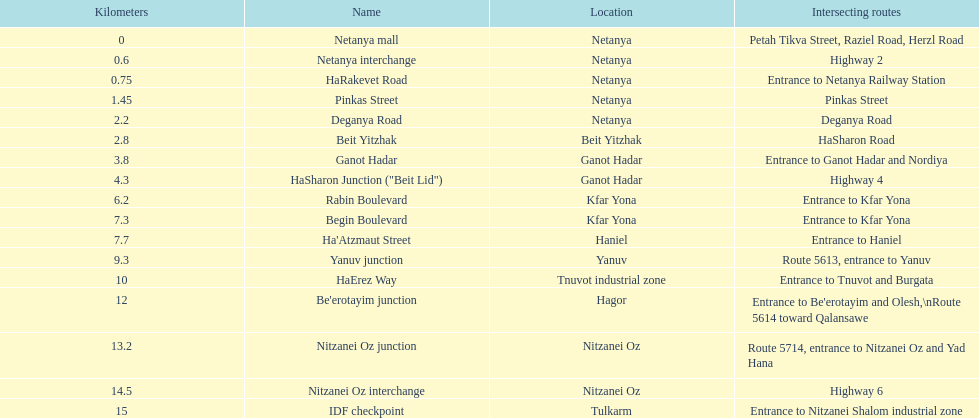How many sections intersect highway 2? 1. 